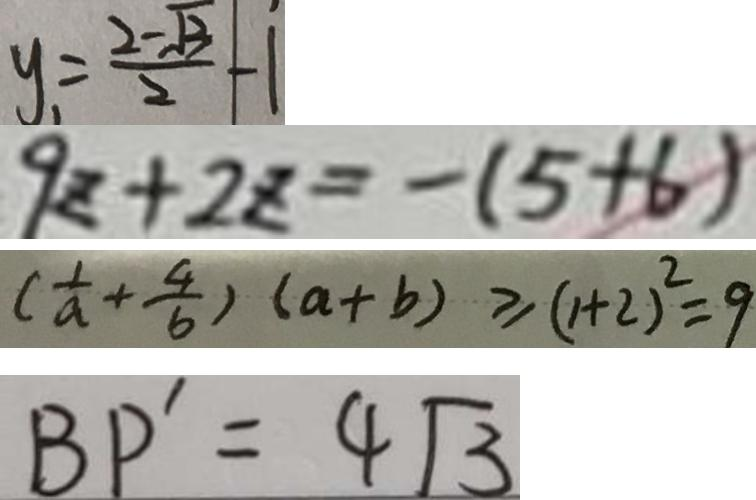Convert formula to latex. <formula><loc_0><loc_0><loc_500><loc_500>y _ { 1 } = \frac { 2 - \sqrt { 3 } } { 2 } - 1 
 9 z + 2 z = - ( 5 + 6 ) 
 ( \frac { 1 } { a } + \frac { 4 } { b } ) ( a + b ) \geq ( 1 + 2 ) ^ { 2 } = 9 
 B P ^ { \prime } = 4 \sqrt { 3 }</formula> 